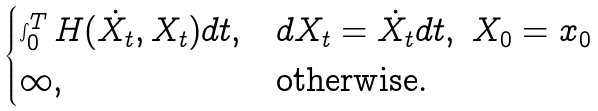<formula> <loc_0><loc_0><loc_500><loc_500>\begin{cases} \int _ { 0 } ^ { T } H ( \dot { X } _ { t } , X _ { t } ) d t , & d X _ { t } = \dot { X } _ { t } d t , \ X _ { 0 } = x _ { 0 } \\ \infty , & \text {otherwise} . \end{cases}</formula> 